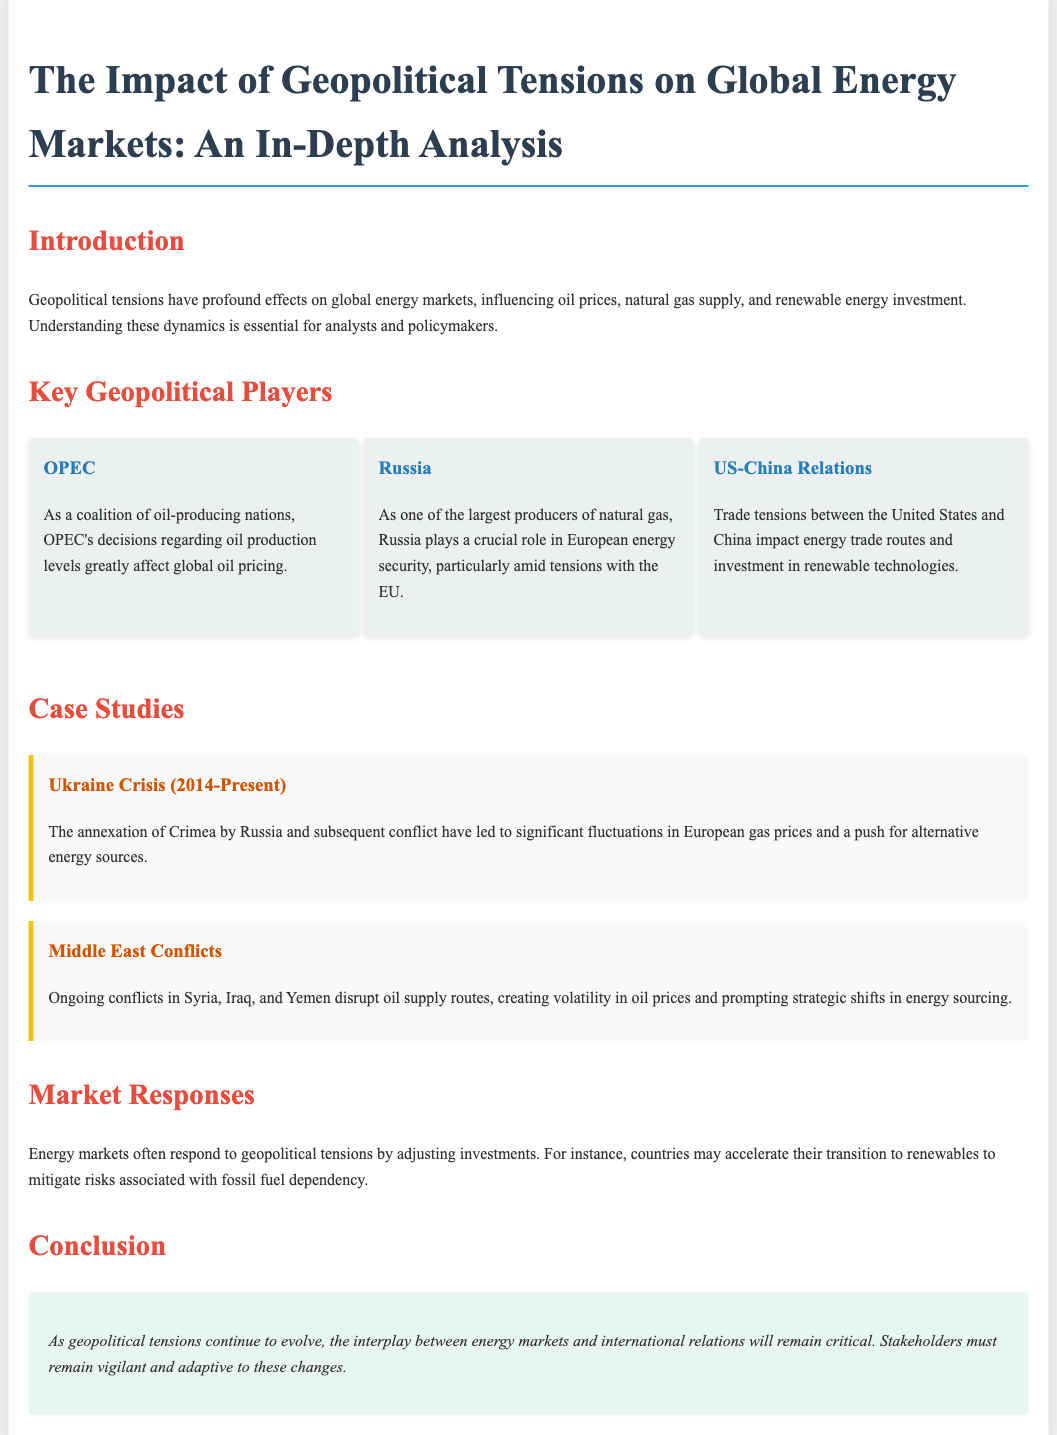What are the key geopolitical players discussed? The document lists OPEC, Russia, and US-China Relations as the key geopolitical players impacting energy markets.
Answer: OPEC, Russia, US-China Relations What is the impact of the Ukraine Crisis mentioned? The document states that the Ukraine Crisis has led to significant fluctuations in European gas prices and a push for alternative energy sources.
Answer: Fluctuations in European gas prices How does OPEC influence global energy markets? The document explains that OPEC's decisions regarding oil production levels greatly affect global oil pricing.
Answer: Oil production levels What is the timeframe of the Ukraine Crisis? The document indicates that the Ukraine Crisis has been ongoing since 2014.
Answer: 2014-Present What are the market responses to geopolitical tensions? The document notes that energy markets respond by adjusting investments and may accelerate the transition to renewables.
Answer: Adjusting investments What type of analysis does this document provide? The document presents an in-depth analysis of the impact of geopolitical tensions on global energy markets.
Answer: In-depth analysis What is the conclusion about geopolitical tensions and energy markets? The conclusion states that the interplay between energy markets and international relations will remain critical.
Answer: Critical What ongoing conflicts disrupt oil supply according to the document? The document mentions ongoing conflicts in Syria, Iraq, and Yemen as disrupting oil supply routes.
Answer: Syria, Iraq, Yemen 